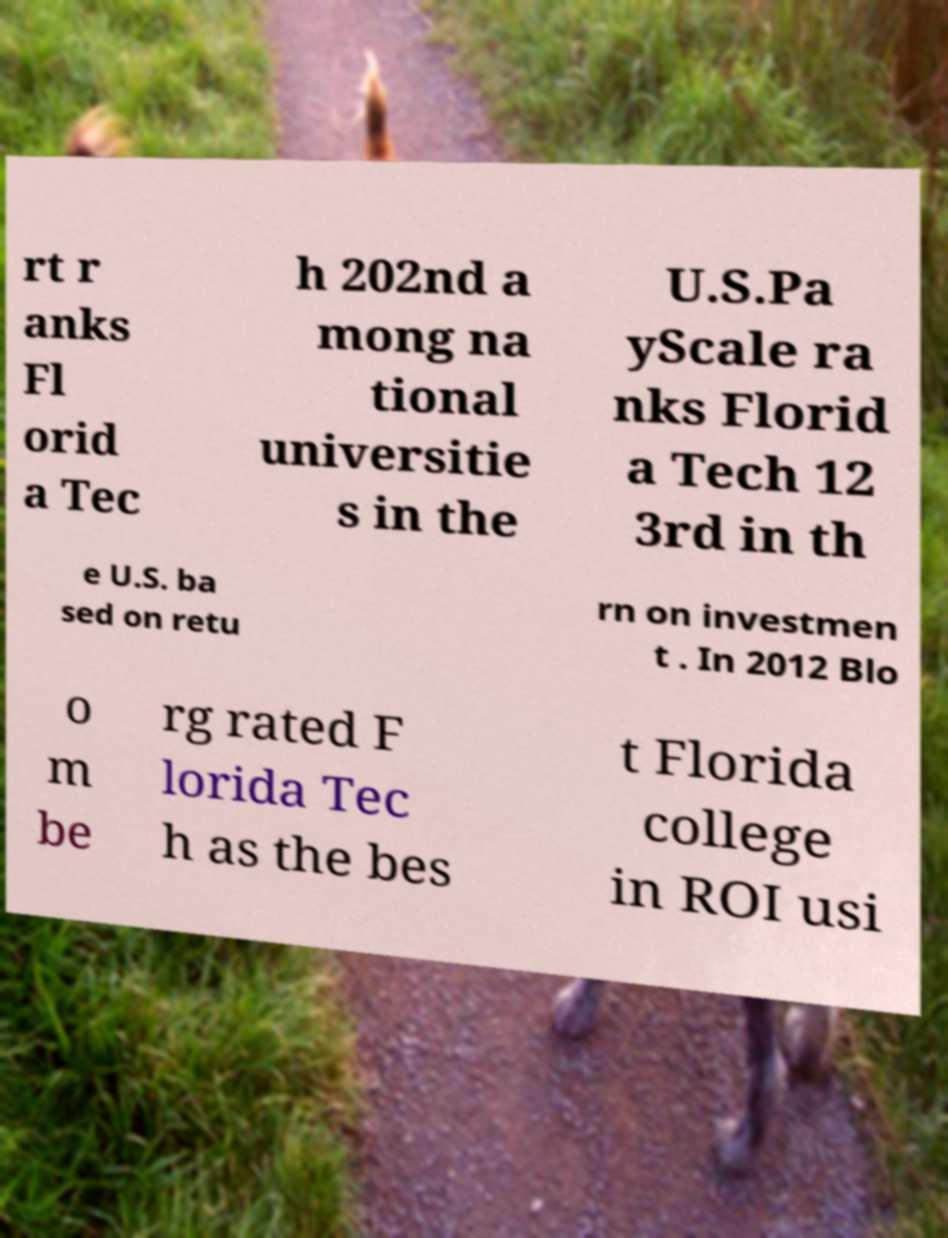Can you read and provide the text displayed in the image?This photo seems to have some interesting text. Can you extract and type it out for me? rt r anks Fl orid a Tec h 202nd a mong na tional universitie s in the U.S.Pa yScale ra nks Florid a Tech 12 3rd in th e U.S. ba sed on retu rn on investmen t . In 2012 Blo o m be rg rated F lorida Tec h as the bes t Florida college in ROI usi 